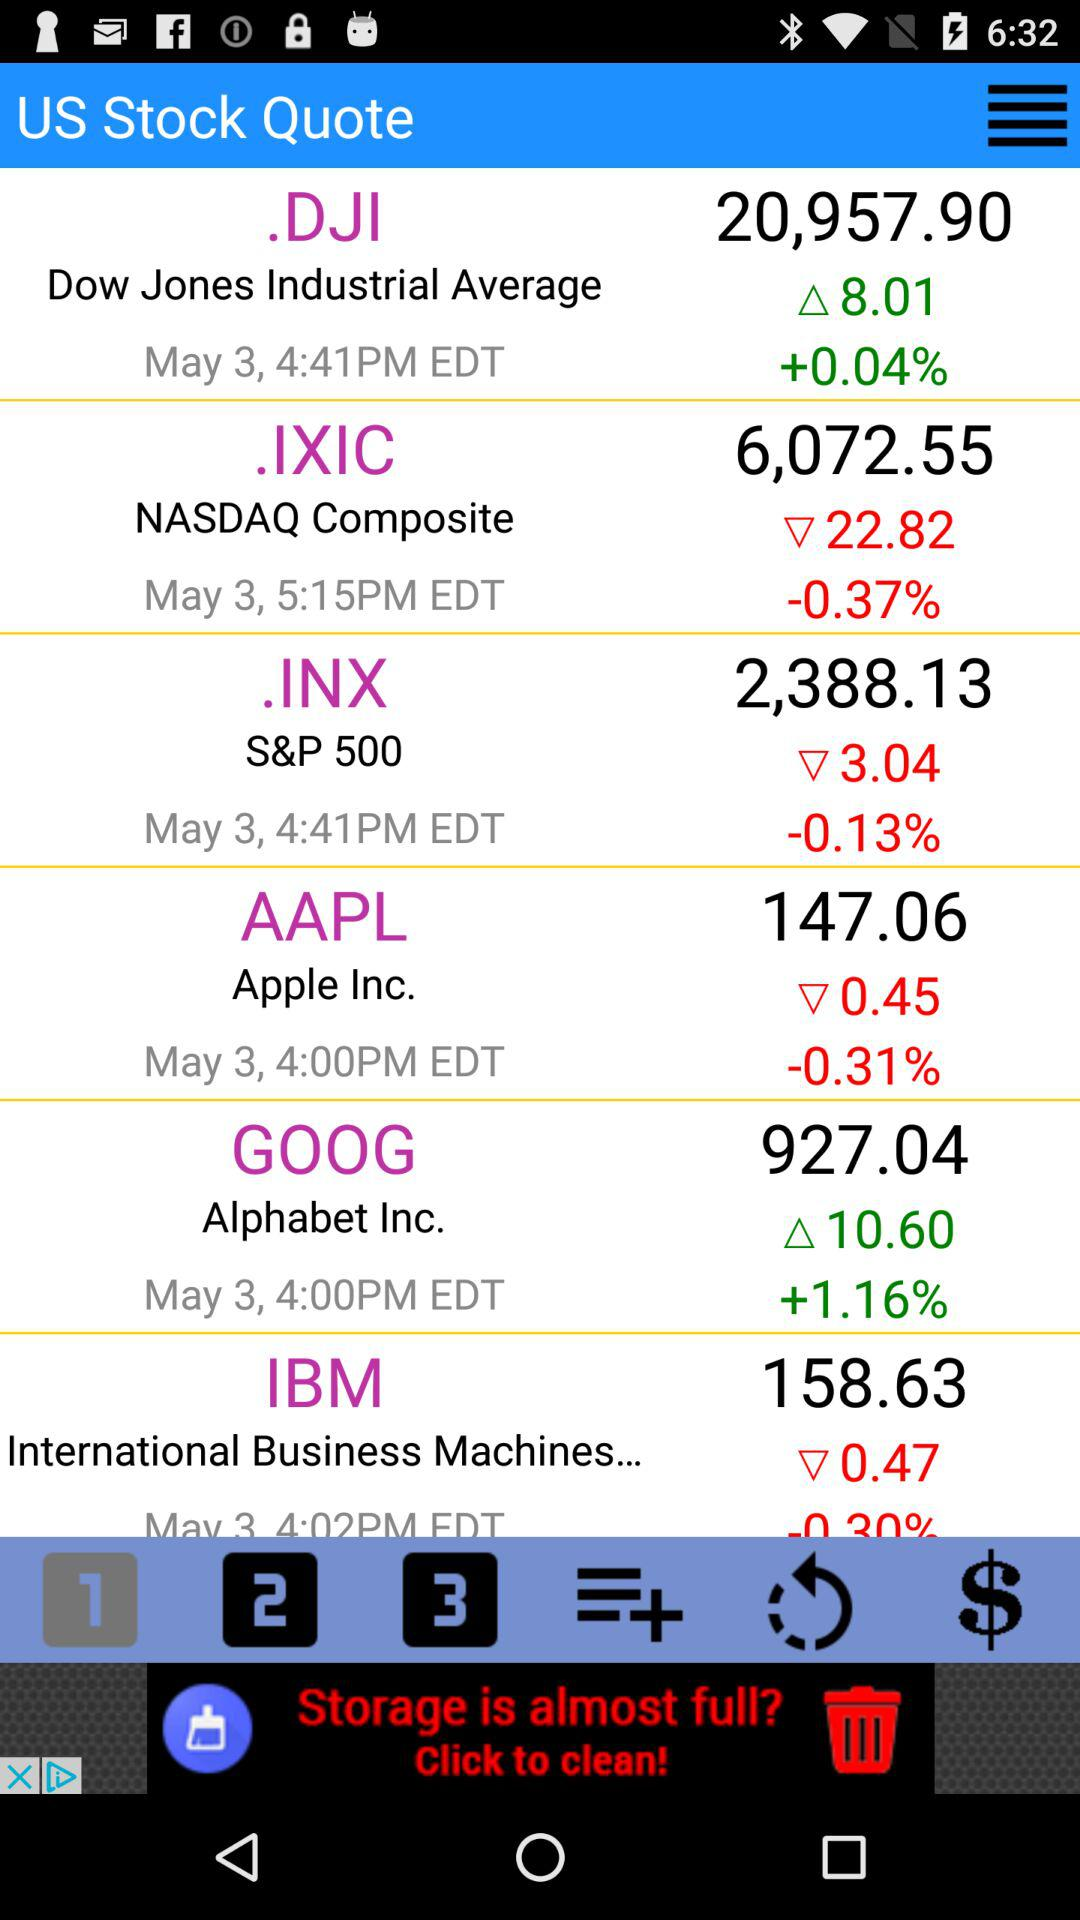What is the growth rate for "GOOG"? The growth rate for "GOOG" is more than 1.16%. 